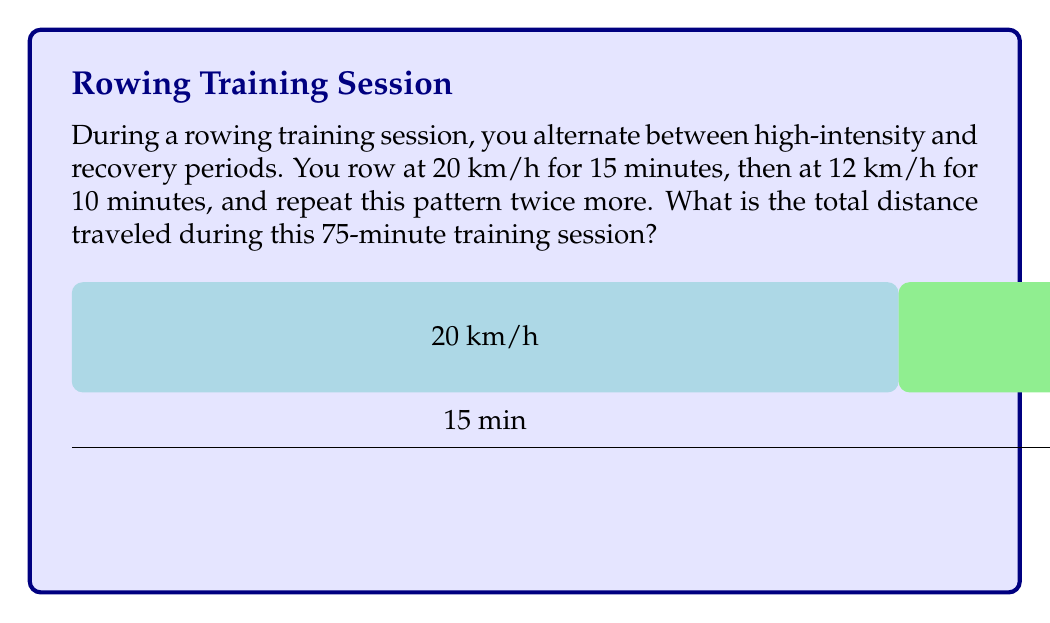Can you answer this question? Let's break this down step-by-step:

1) First, let's calculate the distance traveled in each segment:

   High-intensity segment (20 km/h for 15 minutes):
   $$d_1 = \frac{20 \text{ km/h} \times 15 \text{ min}}{60 \text{ min/h}} = 5 \text{ km}$$

   Recovery segment (12 km/h for 10 minutes):
   $$d_2 = \frac{12 \text{ km/h} \times 10 \text{ min}}{60 \text{ min/h}} = 2 \text{ km}$$

2) Now, we need to add these distances for each repetition:
   $$d_{\text{rep}} = d_1 + d_2 = 5 \text{ km} + 2 \text{ km} = 7 \text{ km}$$

3) The pattern is repeated three times, so we multiply by 3:
   $$d_{\text{total}} = 3 \times d_{\text{rep}} = 3 \times 7 \text{ km} = 21 \text{ km}$$

4) To verify, we can check that the total time adds up to 75 minutes:
   $$(15 \text{ min} + 10 \text{ min}) \times 3 = 75 \text{ min}$$

Therefore, the total distance traveled during the 75-minute training session is 21 km.
Answer: 21 km 